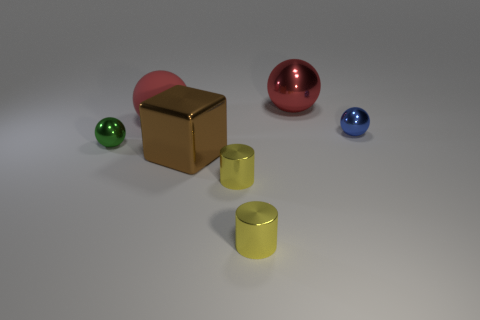Subtract all green spheres. How many spheres are left? 3 Subtract all metallic balls. How many balls are left? 1 Subtract 3 spheres. How many spheres are left? 1 Add 1 brown metal things. How many objects exist? 8 Subtract all purple spheres. How many blue blocks are left? 0 Subtract all yellow metal cylinders. Subtract all big brown metallic blocks. How many objects are left? 4 Add 1 tiny cylinders. How many tiny cylinders are left? 3 Add 2 gray matte blocks. How many gray matte blocks exist? 2 Subtract 0 red cubes. How many objects are left? 7 Subtract all cylinders. How many objects are left? 5 